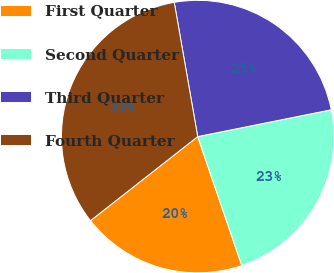<chart> <loc_0><loc_0><loc_500><loc_500><pie_chart><fcel>First Quarter<fcel>Second Quarter<fcel>Third Quarter<fcel>Fourth Quarter<nl><fcel>19.66%<fcel>22.91%<fcel>24.6%<fcel>32.83%<nl></chart> 